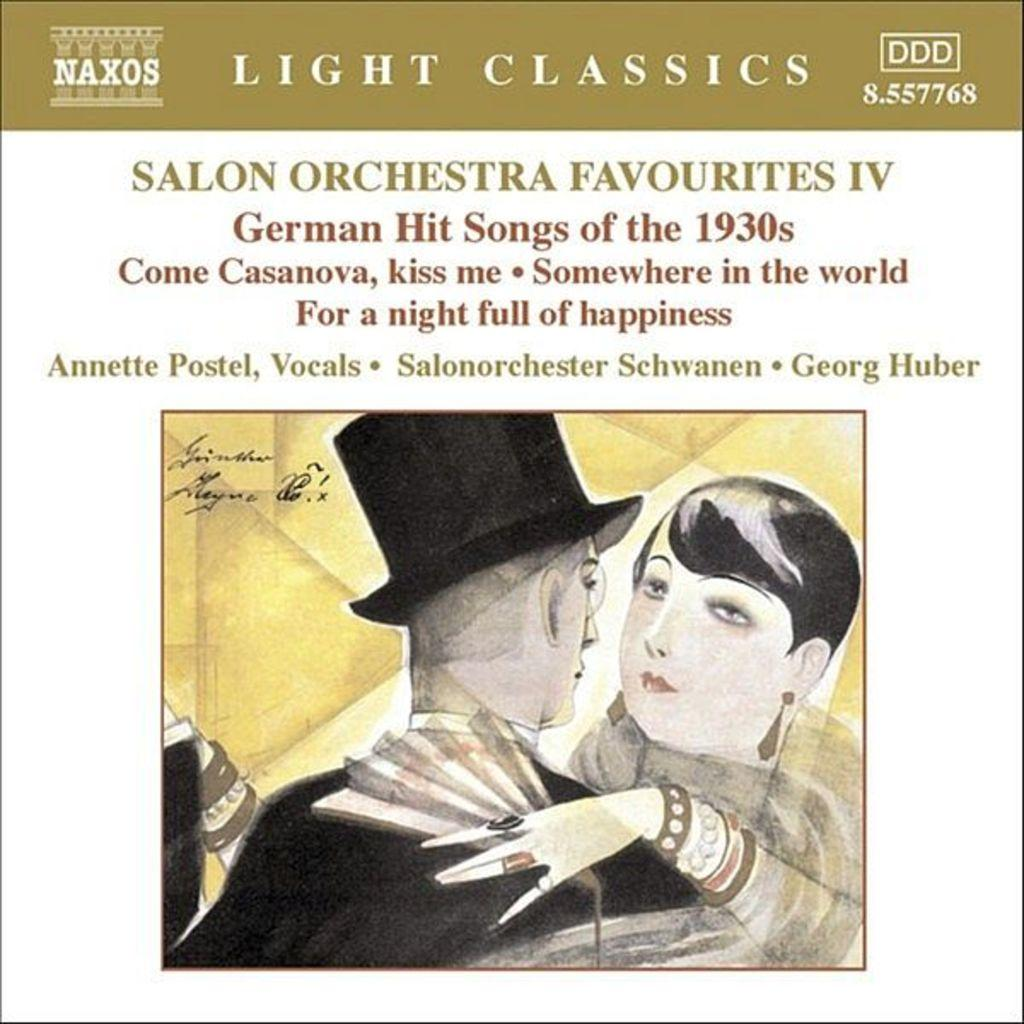What subjects are depicted in the paintings in the image? There is a painting of a woman and a painting of a man in the image. What is written at the top of the image? There is text written at the top of the image. Can you hear the tramp playing the trumpet in the image? There is no tramp or trumpet present in the image; it only contains paintings of a woman and a man, along with text at the top. 